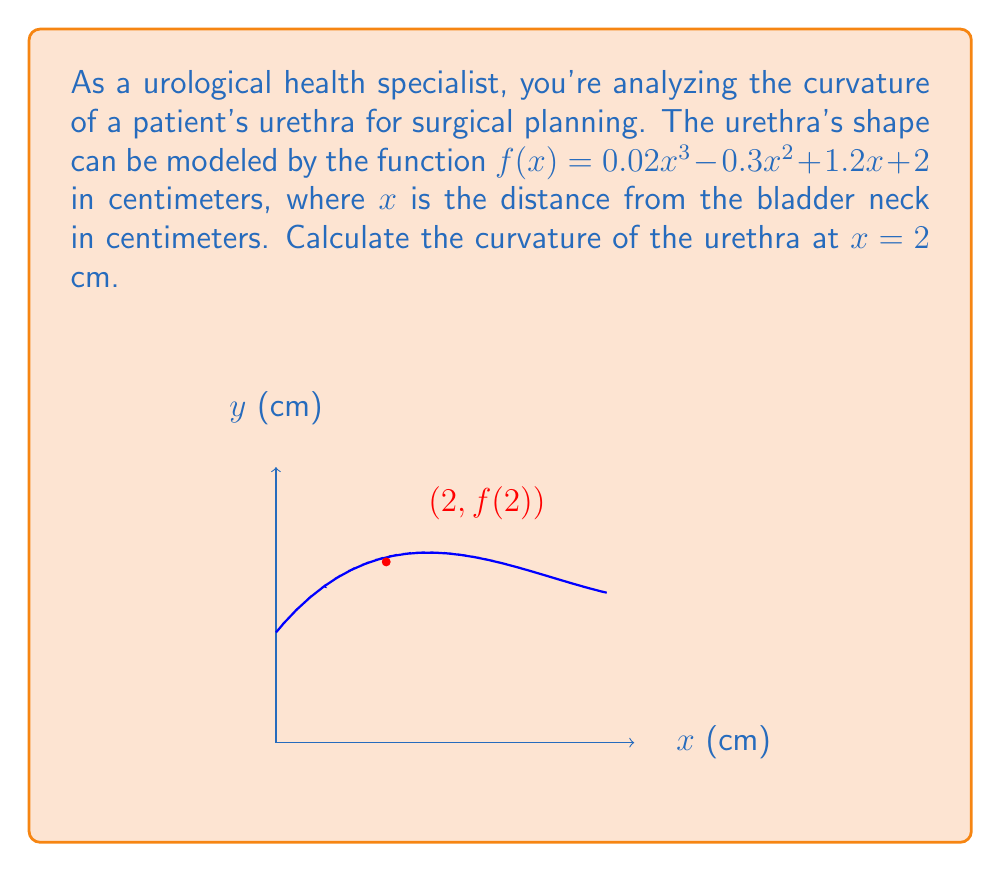What is the answer to this math problem? To calculate the curvature at a point, we use the formula:

$$ \kappa = \frac{|f''(x)|}{(1 + [f'(x)]^2)^{3/2}} $$

Step 1: Find $f'(x)$
$$ f'(x) = 0.06x^2 - 0.6x + 1.2 $$

Step 2: Find $f''(x)$
$$ f''(x) = 0.12x - 0.6 $$

Step 3: Calculate $f'(2)$ and $f''(2)$
$$ f'(2) = 0.06(2)^2 - 0.6(2) + 1.2 = 0.24 - 1.2 + 1.2 = 0.24 $$
$$ f''(2) = 0.12(2) - 0.6 = 0.24 - 0.6 = -0.36 $$

Step 4: Substitute into the curvature formula
$$ \kappa = \frac{|-0.36|}{(1 + [0.24]^2)^{3/2}} = \frac{0.36}{(1 + 0.0576)^{3/2}} = \frac{0.36}{1.0576^{3/2}} $$

Step 5: Calculate the final result
$$ \kappa \approx 0.3378 \text{ cm}^{-1} $$
Answer: $0.3378 \text{ cm}^{-1}$ 